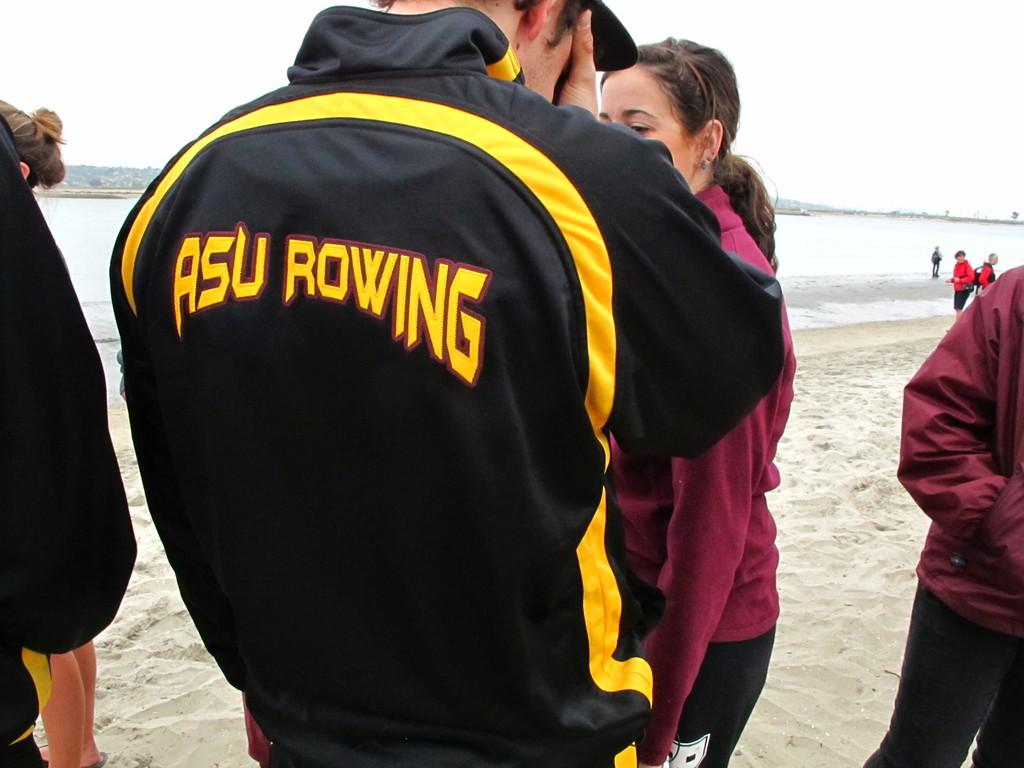What is the surface that the persons are standing on in the image? The persons are standing on the sand in the image. What can be seen in the background of the image? There is water visible in the image, and there is also a mountain in the image. What type of organization is depicted in the image? There is no organization depicted in the image; it features persons standing on the sand, water, and a mountain. Can you tell me how many sidewalks are visible in the image? There are no sidewalks present in the image. 